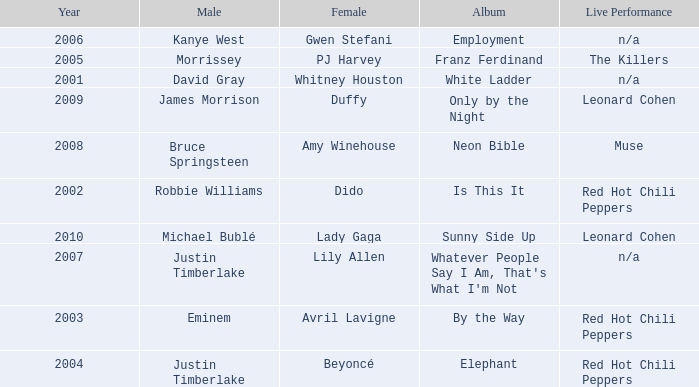Who is the male partner for amy winehouse? Bruce Springsteen. 